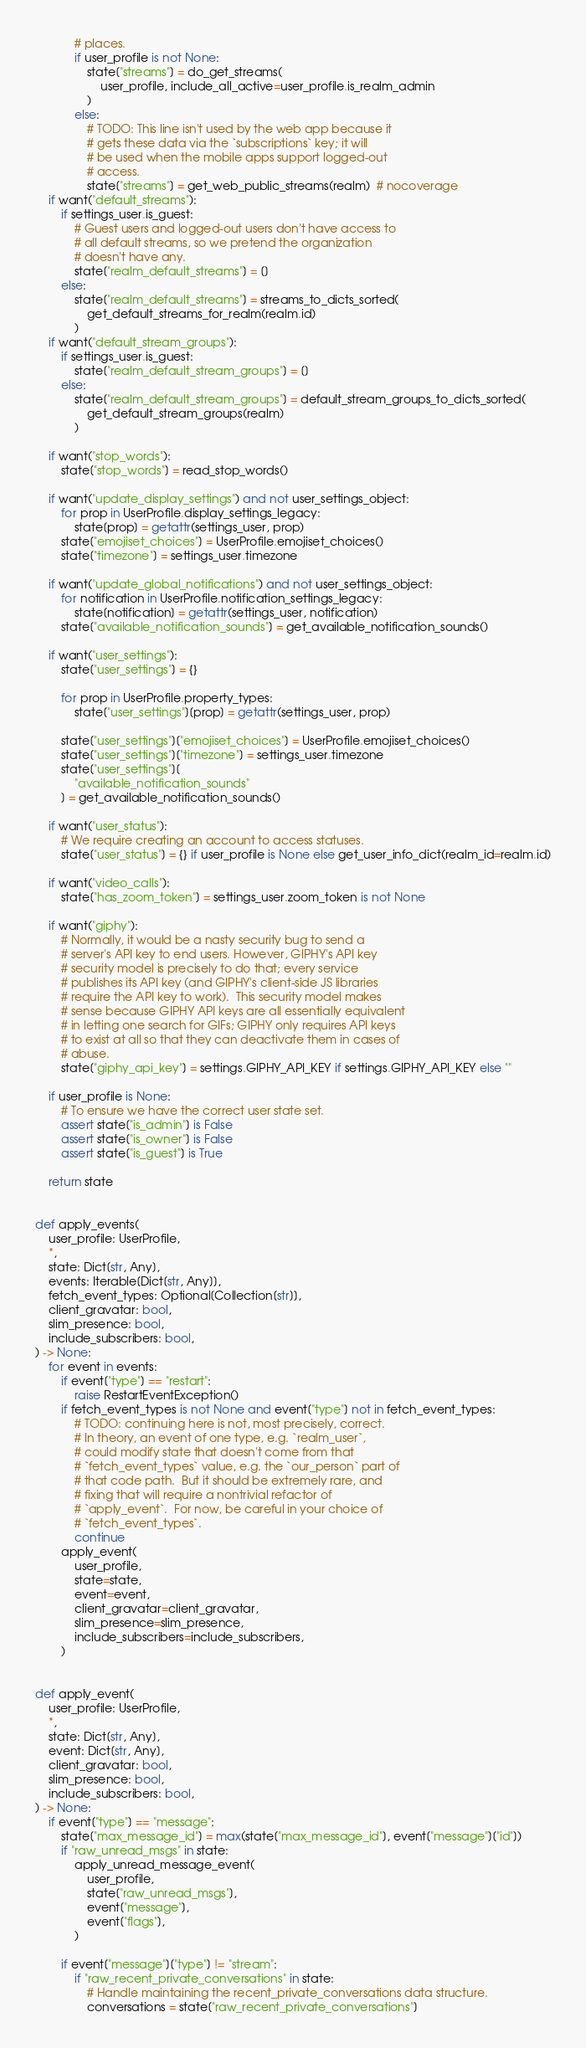Convert code to text. <code><loc_0><loc_0><loc_500><loc_500><_Python_>            # places.
            if user_profile is not None:
                state["streams"] = do_get_streams(
                    user_profile, include_all_active=user_profile.is_realm_admin
                )
            else:
                # TODO: This line isn't used by the web app because it
                # gets these data via the `subscriptions` key; it will
                # be used when the mobile apps support logged-out
                # access.
                state["streams"] = get_web_public_streams(realm)  # nocoverage
    if want("default_streams"):
        if settings_user.is_guest:
            # Guest users and logged-out users don't have access to
            # all default streams, so we pretend the organization
            # doesn't have any.
            state["realm_default_streams"] = []
        else:
            state["realm_default_streams"] = streams_to_dicts_sorted(
                get_default_streams_for_realm(realm.id)
            )
    if want("default_stream_groups"):
        if settings_user.is_guest:
            state["realm_default_stream_groups"] = []
        else:
            state["realm_default_stream_groups"] = default_stream_groups_to_dicts_sorted(
                get_default_stream_groups(realm)
            )

    if want("stop_words"):
        state["stop_words"] = read_stop_words()

    if want("update_display_settings") and not user_settings_object:
        for prop in UserProfile.display_settings_legacy:
            state[prop] = getattr(settings_user, prop)
        state["emojiset_choices"] = UserProfile.emojiset_choices()
        state["timezone"] = settings_user.timezone

    if want("update_global_notifications") and not user_settings_object:
        for notification in UserProfile.notification_settings_legacy:
            state[notification] = getattr(settings_user, notification)
        state["available_notification_sounds"] = get_available_notification_sounds()

    if want("user_settings"):
        state["user_settings"] = {}

        for prop in UserProfile.property_types:
            state["user_settings"][prop] = getattr(settings_user, prop)

        state["user_settings"]["emojiset_choices"] = UserProfile.emojiset_choices()
        state["user_settings"]["timezone"] = settings_user.timezone
        state["user_settings"][
            "available_notification_sounds"
        ] = get_available_notification_sounds()

    if want("user_status"):
        # We require creating an account to access statuses.
        state["user_status"] = {} if user_profile is None else get_user_info_dict(realm_id=realm.id)

    if want("video_calls"):
        state["has_zoom_token"] = settings_user.zoom_token is not None

    if want("giphy"):
        # Normally, it would be a nasty security bug to send a
        # server's API key to end users. However, GIPHY's API key
        # security model is precisely to do that; every service
        # publishes its API key (and GIPHY's client-side JS libraries
        # require the API key to work).  This security model makes
        # sense because GIPHY API keys are all essentially equivalent
        # in letting one search for GIFs; GIPHY only requires API keys
        # to exist at all so that they can deactivate them in cases of
        # abuse.
        state["giphy_api_key"] = settings.GIPHY_API_KEY if settings.GIPHY_API_KEY else ""

    if user_profile is None:
        # To ensure we have the correct user state set.
        assert state["is_admin"] is False
        assert state["is_owner"] is False
        assert state["is_guest"] is True

    return state


def apply_events(
    user_profile: UserProfile,
    *,
    state: Dict[str, Any],
    events: Iterable[Dict[str, Any]],
    fetch_event_types: Optional[Collection[str]],
    client_gravatar: bool,
    slim_presence: bool,
    include_subscribers: bool,
) -> None:
    for event in events:
        if event["type"] == "restart":
            raise RestartEventException()
        if fetch_event_types is not None and event["type"] not in fetch_event_types:
            # TODO: continuing here is not, most precisely, correct.
            # In theory, an event of one type, e.g. `realm_user`,
            # could modify state that doesn't come from that
            # `fetch_event_types` value, e.g. the `our_person` part of
            # that code path.  But it should be extremely rare, and
            # fixing that will require a nontrivial refactor of
            # `apply_event`.  For now, be careful in your choice of
            # `fetch_event_types`.
            continue
        apply_event(
            user_profile,
            state=state,
            event=event,
            client_gravatar=client_gravatar,
            slim_presence=slim_presence,
            include_subscribers=include_subscribers,
        )


def apply_event(
    user_profile: UserProfile,
    *,
    state: Dict[str, Any],
    event: Dict[str, Any],
    client_gravatar: bool,
    slim_presence: bool,
    include_subscribers: bool,
) -> None:
    if event["type"] == "message":
        state["max_message_id"] = max(state["max_message_id"], event["message"]["id"])
        if "raw_unread_msgs" in state:
            apply_unread_message_event(
                user_profile,
                state["raw_unread_msgs"],
                event["message"],
                event["flags"],
            )

        if event["message"]["type"] != "stream":
            if "raw_recent_private_conversations" in state:
                # Handle maintaining the recent_private_conversations data structure.
                conversations = state["raw_recent_private_conversations"]</code> 